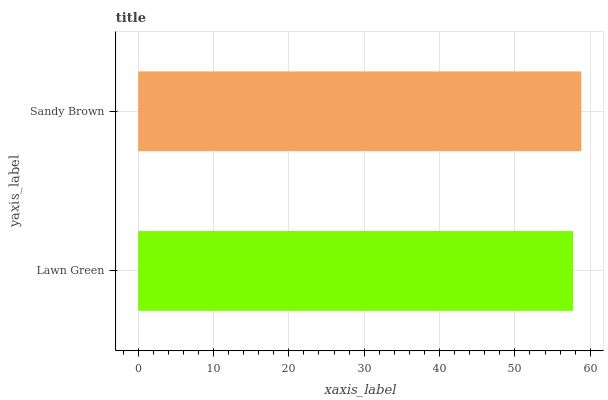Is Lawn Green the minimum?
Answer yes or no. Yes. Is Sandy Brown the maximum?
Answer yes or no. Yes. Is Sandy Brown the minimum?
Answer yes or no. No. Is Sandy Brown greater than Lawn Green?
Answer yes or no. Yes. Is Lawn Green less than Sandy Brown?
Answer yes or no. Yes. Is Lawn Green greater than Sandy Brown?
Answer yes or no. No. Is Sandy Brown less than Lawn Green?
Answer yes or no. No. Is Sandy Brown the high median?
Answer yes or no. Yes. Is Lawn Green the low median?
Answer yes or no. Yes. Is Lawn Green the high median?
Answer yes or no. No. Is Sandy Brown the low median?
Answer yes or no. No. 